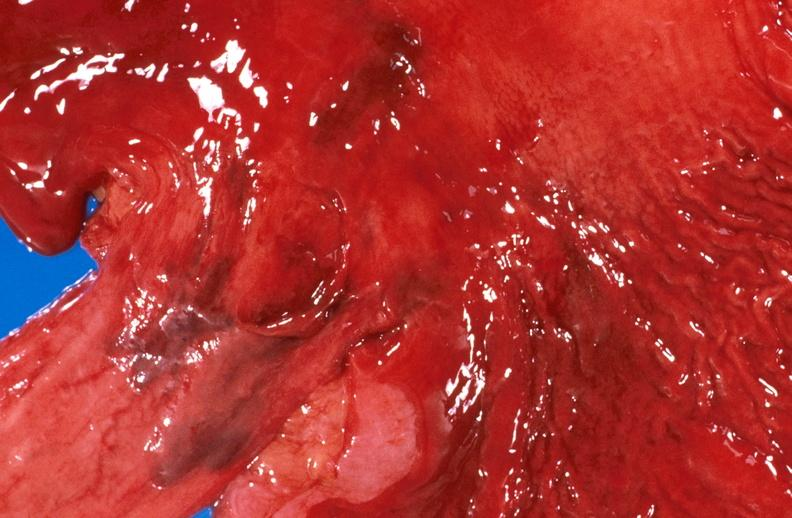does yo show esophageal varices due to alcoholic cirrhosis?
Answer the question using a single word or phrase. No 